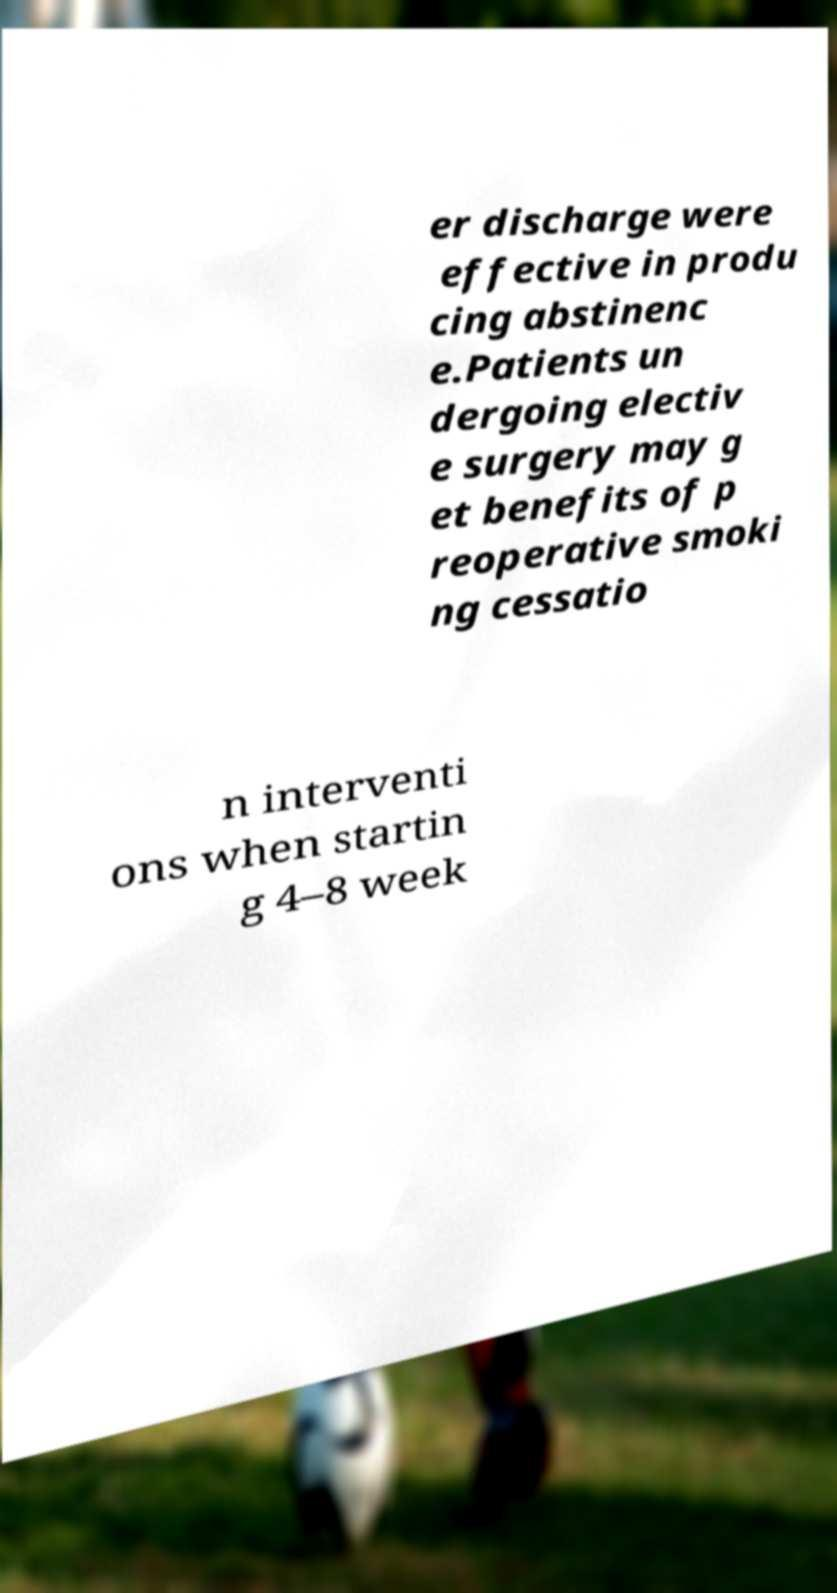I need the written content from this picture converted into text. Can you do that? er discharge were effective in produ cing abstinenc e.Patients un dergoing electiv e surgery may g et benefits of p reoperative smoki ng cessatio n interventi ons when startin g 4–8 week 